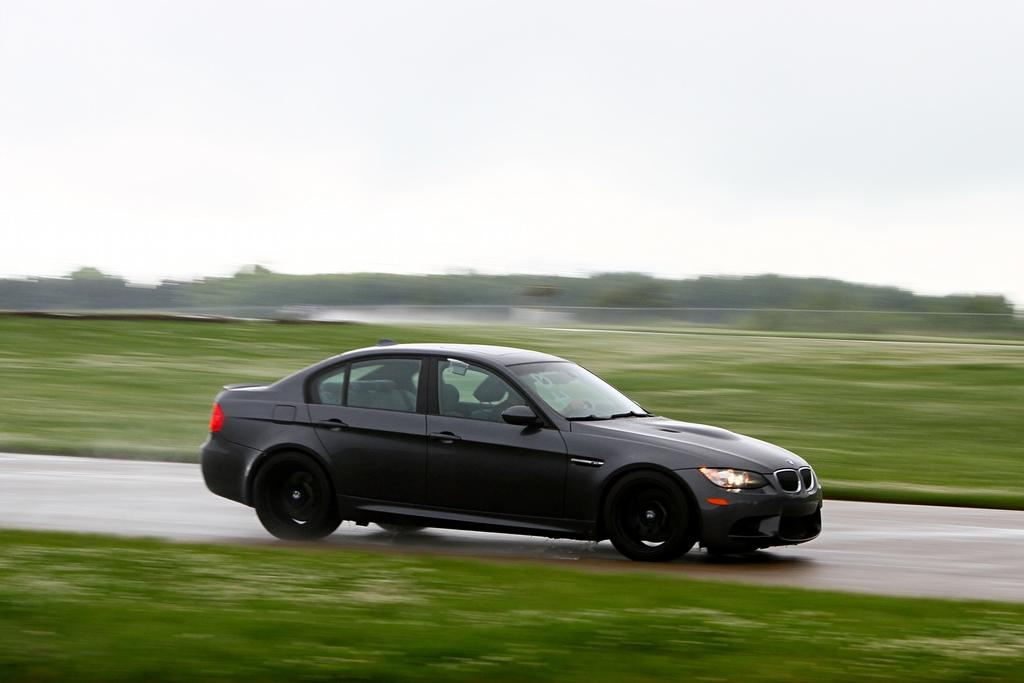What is the main subject of the image? There is a person driving a car in the image. What type of environment is visible in the image? There are many trees and a grassy land in the image. What color is the fireman's hat in the image? There is no fireman or hat present in the image. How many silver objects can be seen in the image? There is no mention of silver objects in the image, so it is impossible to determine their number. 